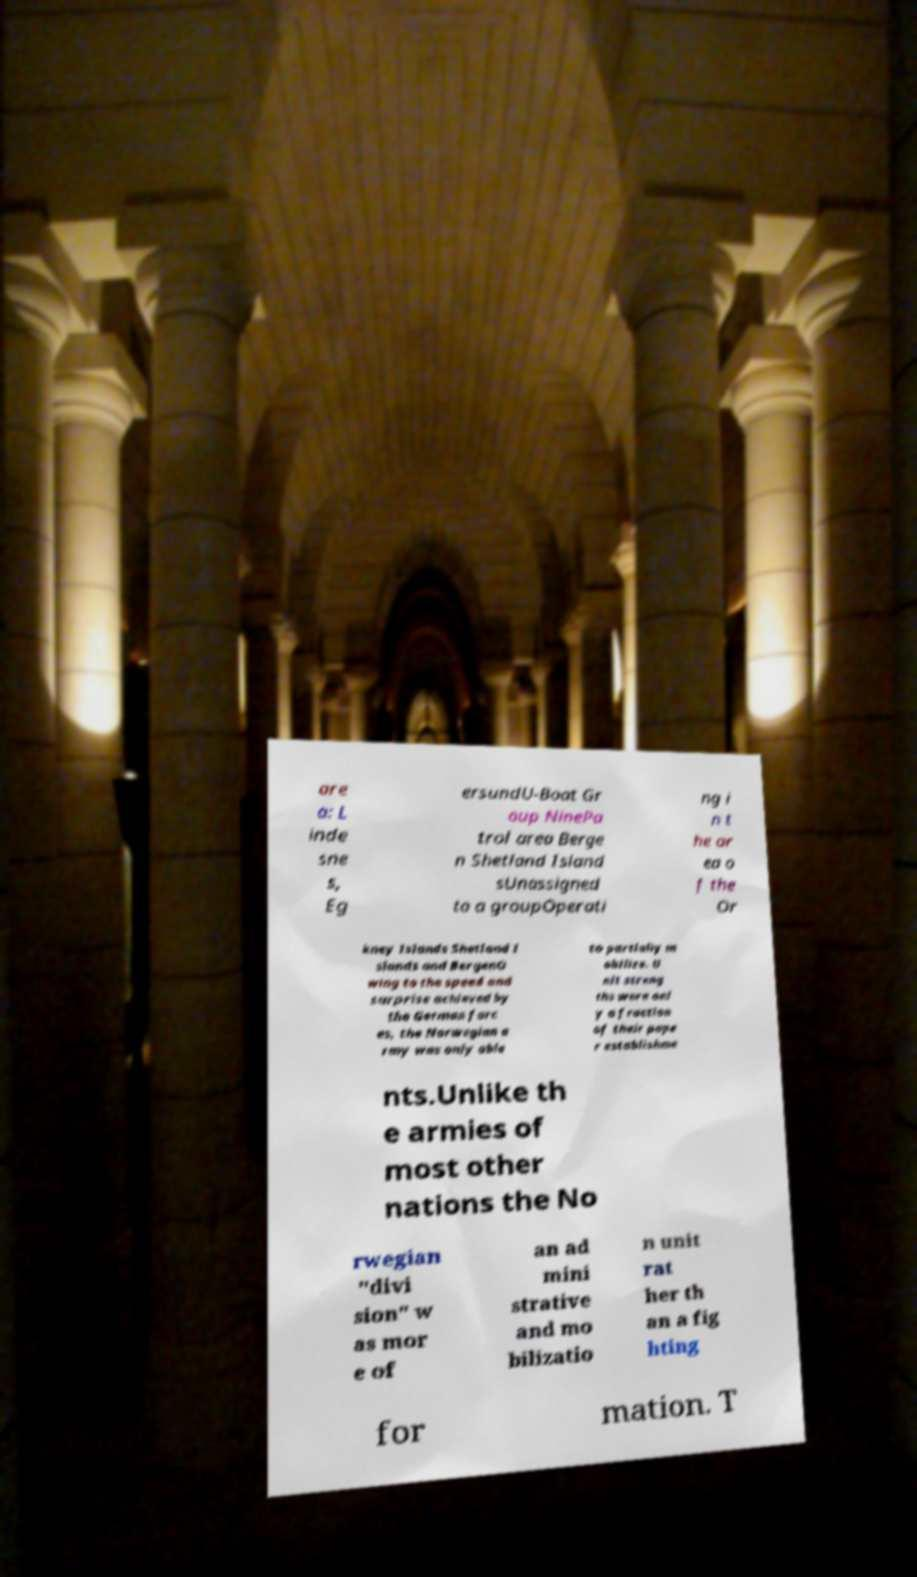Please read and relay the text visible in this image. What does it say? are a: L inde sne s, Eg ersundU-Boat Gr oup NinePa trol area Berge n Shetland Island sUnassigned to a groupOperati ng i n t he ar ea o f the Or kney Islands Shetland I slands and BergenO wing to the speed and surprise achieved by the German forc es, the Norwegian a rmy was only able to partially m obilize. U nit streng ths were onl y a fraction of their pape r establishme nts.Unlike th e armies of most other nations the No rwegian "divi sion" w as mor e of an ad mini strative and mo bilizatio n unit rat her th an a fig hting for mation. T 